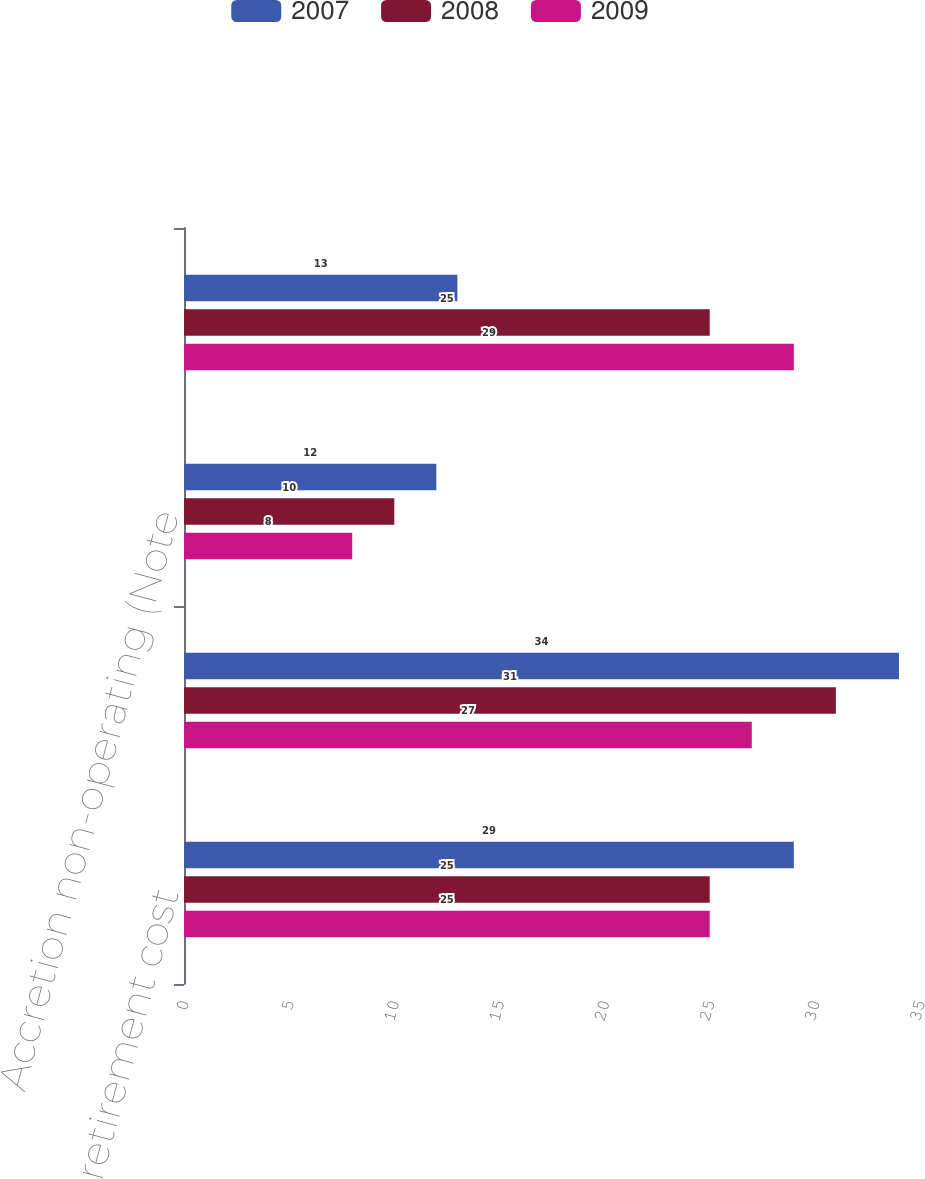Convert chart. <chart><loc_0><loc_0><loc_500><loc_500><stacked_bar_chart><ecel><fcel>Asset retirement cost<fcel>Accretion operating<fcel>Accretion non-operating (Note<fcel>Reclamation estimate revisions<nl><fcel>2007<fcel>29<fcel>34<fcel>12<fcel>13<nl><fcel>2008<fcel>25<fcel>31<fcel>10<fcel>25<nl><fcel>2009<fcel>25<fcel>27<fcel>8<fcel>29<nl></chart> 